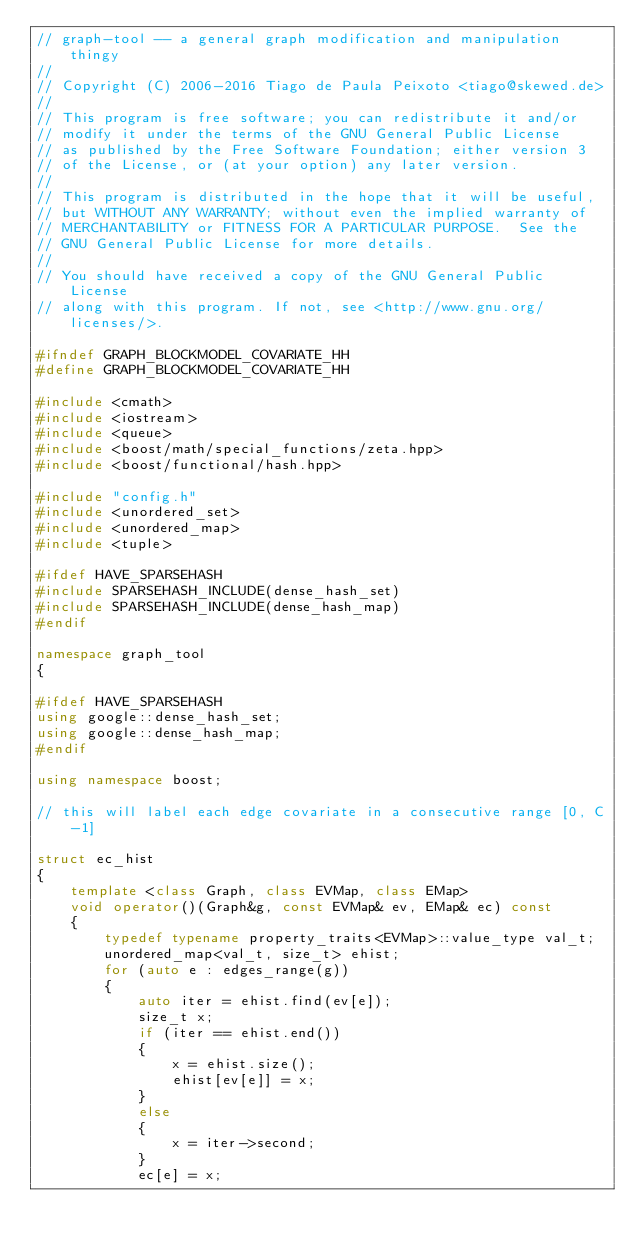<code> <loc_0><loc_0><loc_500><loc_500><_C++_>// graph-tool -- a general graph modification and manipulation thingy
//
// Copyright (C) 2006-2016 Tiago de Paula Peixoto <tiago@skewed.de>
//
// This program is free software; you can redistribute it and/or
// modify it under the terms of the GNU General Public License
// as published by the Free Software Foundation; either version 3
// of the License, or (at your option) any later version.
//
// This program is distributed in the hope that it will be useful,
// but WITHOUT ANY WARRANTY; without even the implied warranty of
// MERCHANTABILITY or FITNESS FOR A PARTICULAR PURPOSE.  See the
// GNU General Public License for more details.
//
// You should have received a copy of the GNU General Public License
// along with this program. If not, see <http://www.gnu.org/licenses/>.

#ifndef GRAPH_BLOCKMODEL_COVARIATE_HH
#define GRAPH_BLOCKMODEL_COVARIATE_HH

#include <cmath>
#include <iostream>
#include <queue>
#include <boost/math/special_functions/zeta.hpp>
#include <boost/functional/hash.hpp>

#include "config.h"
#include <unordered_set>
#include <unordered_map>
#include <tuple>

#ifdef HAVE_SPARSEHASH
#include SPARSEHASH_INCLUDE(dense_hash_set)
#include SPARSEHASH_INCLUDE(dense_hash_map)
#endif

namespace graph_tool
{

#ifdef HAVE_SPARSEHASH
using google::dense_hash_set;
using google::dense_hash_map;
#endif

using namespace boost;

// this will label each edge covariate in a consecutive range [0, C-1]

struct ec_hist
{
    template <class Graph, class EVMap, class EMap>
    void operator()(Graph&g, const EVMap& ev, EMap& ec) const
    {
        typedef typename property_traits<EVMap>::value_type val_t;
        unordered_map<val_t, size_t> ehist;
        for (auto e : edges_range(g))
        {
            auto iter = ehist.find(ev[e]);
            size_t x;
            if (iter == ehist.end())
            {
                x = ehist.size();
                ehist[ev[e]] = x;
            }
            else
            {
                x = iter->second;
            }
            ec[e] = x;</code> 